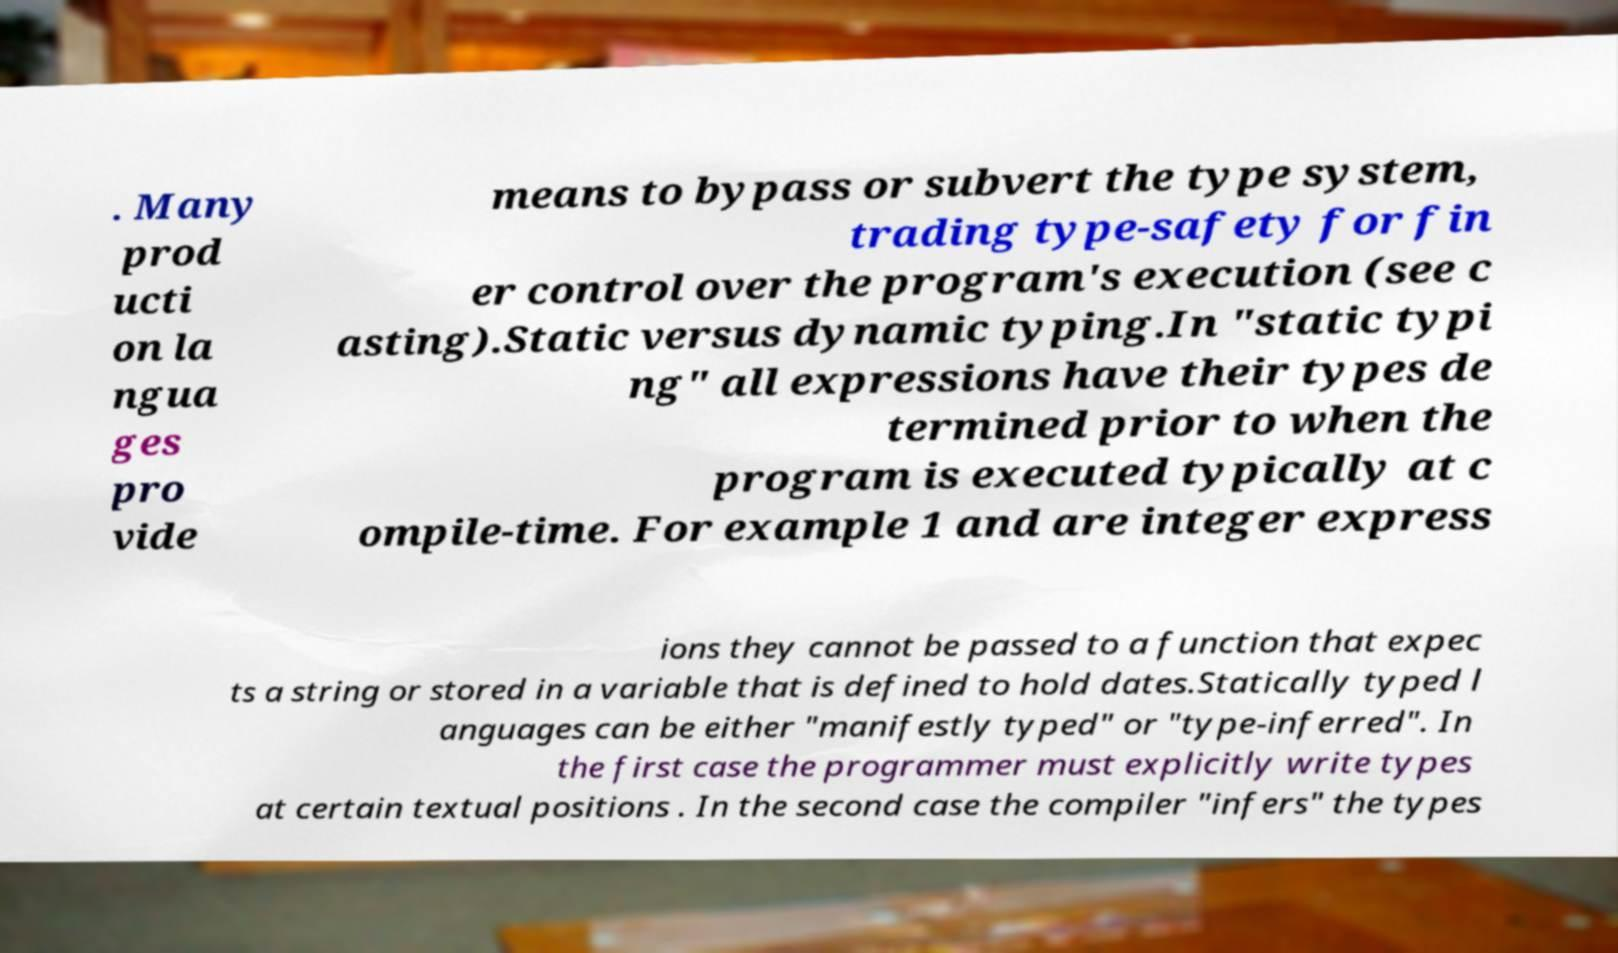Could you extract and type out the text from this image? . Many prod ucti on la ngua ges pro vide means to bypass or subvert the type system, trading type-safety for fin er control over the program's execution (see c asting).Static versus dynamic typing.In "static typi ng" all expressions have their types de termined prior to when the program is executed typically at c ompile-time. For example 1 and are integer express ions they cannot be passed to a function that expec ts a string or stored in a variable that is defined to hold dates.Statically typed l anguages can be either "manifestly typed" or "type-inferred". In the first case the programmer must explicitly write types at certain textual positions . In the second case the compiler "infers" the types 